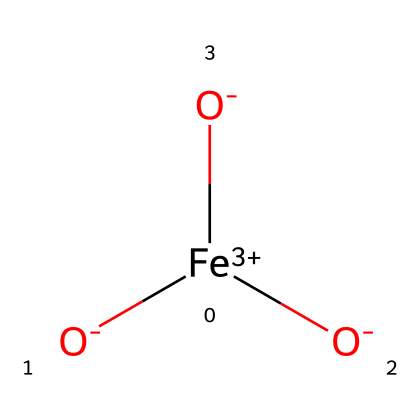What is the central metal ion in this pigment? The chemical has the notation of [Cu+2], indicating that copper (Cu) is the central metal ion in this basic copper carbonate structure.
Answer: copper How many hydroxide (OH) groups are present in this structure? By analyzing the chemical representation, there are two (OH) groups noted in the formula, indicating their presence.
Answer: two What is the oxidation state of copper in this compound? The notation [Cu+2] shows that copper is in the +2 oxidation state, as indicated by the positive charge associated with it.
Answer: +2 Which type of carbonate is present in this pigment? The presence of (CO3) in the chemical structure suggests that it is a basic carbonate, commonly referred to as a carbonate ion.
Answer: basic carbonate What is the formula that indicates the presence of lead in this chemical? The structure shows Pb3, indicating that lead is a crucial component of the pigment, specifically in its compound form within lead white.
Answer: Pb3 How does the presence of copper ions contribute to the color of this pigment? The [Cu+2] ions are typically associated with blue pigments, indicating that the copper ions give the pigment its characteristic blue color.
Answer: blue 